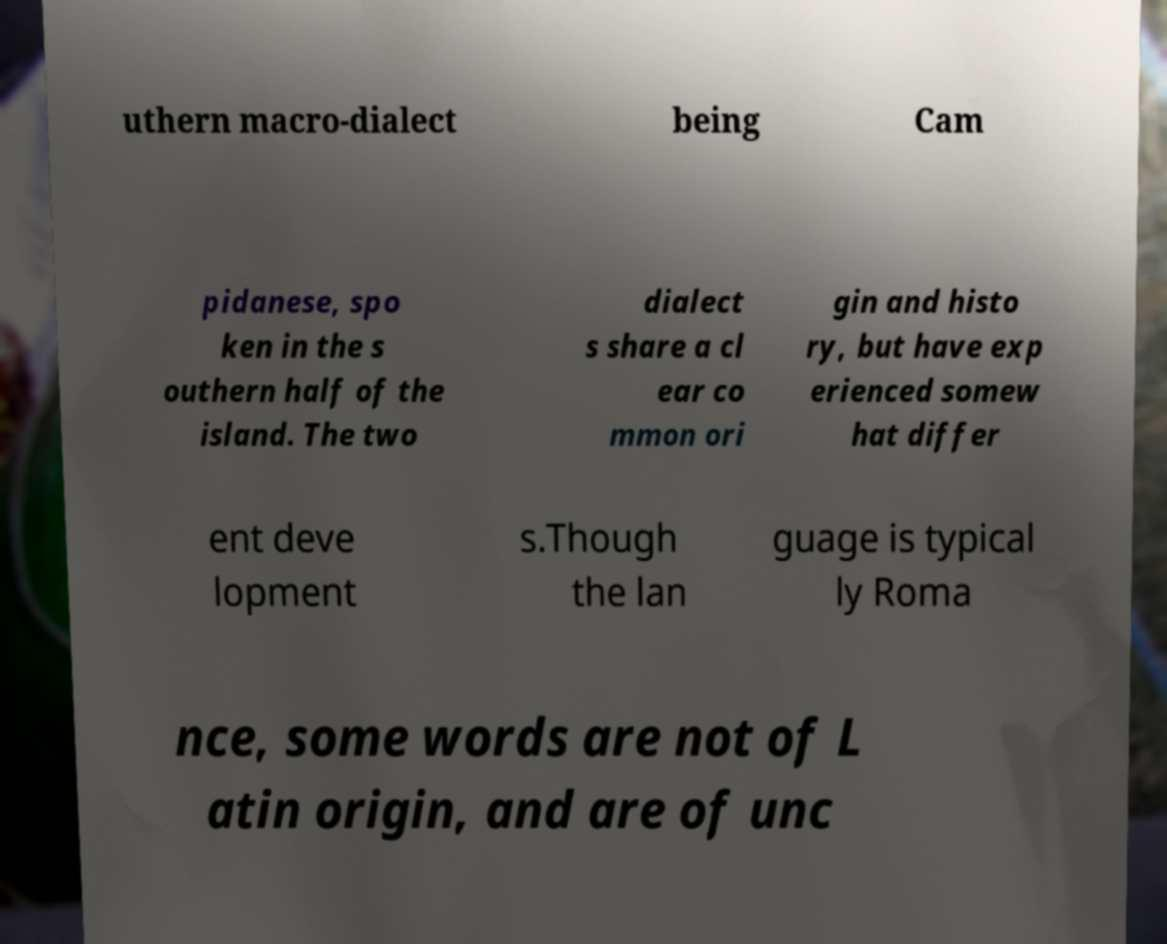Can you accurately transcribe the text from the provided image for me? uthern macro-dialect being Cam pidanese, spo ken in the s outhern half of the island. The two dialect s share a cl ear co mmon ori gin and histo ry, but have exp erienced somew hat differ ent deve lopment s.Though the lan guage is typical ly Roma nce, some words are not of L atin origin, and are of unc 